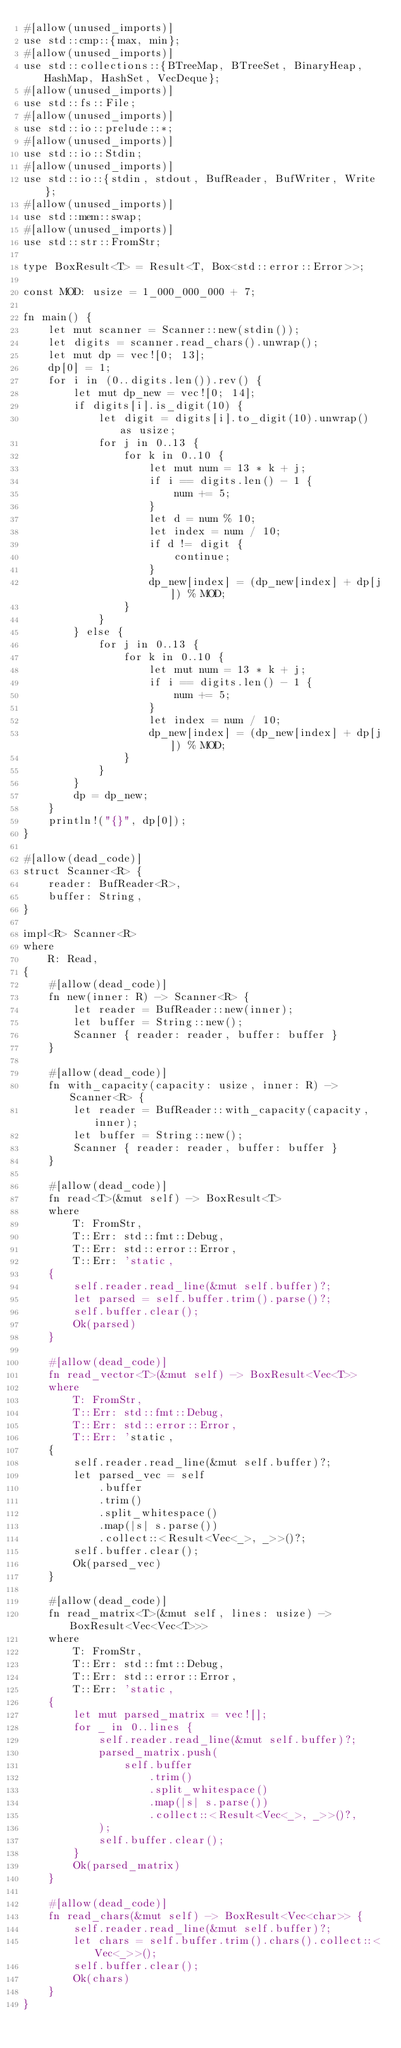Convert code to text. <code><loc_0><loc_0><loc_500><loc_500><_Rust_>#[allow(unused_imports)]
use std::cmp::{max, min};
#[allow(unused_imports)]
use std::collections::{BTreeMap, BTreeSet, BinaryHeap, HashMap, HashSet, VecDeque};
#[allow(unused_imports)]
use std::fs::File;
#[allow(unused_imports)]
use std::io::prelude::*;
#[allow(unused_imports)]
use std::io::Stdin;
#[allow(unused_imports)]
use std::io::{stdin, stdout, BufReader, BufWriter, Write};
#[allow(unused_imports)]
use std::mem::swap;
#[allow(unused_imports)]
use std::str::FromStr;

type BoxResult<T> = Result<T, Box<std::error::Error>>;

const MOD: usize = 1_000_000_000 + 7;

fn main() {
    let mut scanner = Scanner::new(stdin());
    let digits = scanner.read_chars().unwrap();
    let mut dp = vec![0; 13];
    dp[0] = 1;
    for i in (0..digits.len()).rev() {
        let mut dp_new = vec![0; 14];
        if digits[i].is_digit(10) {
            let digit = digits[i].to_digit(10).unwrap() as usize;
            for j in 0..13 {
                for k in 0..10 {
                    let mut num = 13 * k + j;
                    if i == digits.len() - 1 {
                        num += 5;
                    }
                    let d = num % 10;
                    let index = num / 10;
                    if d != digit {
                        continue;
                    }
                    dp_new[index] = (dp_new[index] + dp[j]) % MOD;
                }
            }
        } else {
            for j in 0..13 {
                for k in 0..10 {
                    let mut num = 13 * k + j;
                    if i == digits.len() - 1 {
                        num += 5;
                    }
                    let index = num / 10;
                    dp_new[index] = (dp_new[index] + dp[j]) % MOD;
                }
            }
        }
        dp = dp_new;
    }
    println!("{}", dp[0]);
}

#[allow(dead_code)]
struct Scanner<R> {
    reader: BufReader<R>,
    buffer: String,
}

impl<R> Scanner<R>
where
    R: Read,
{
    #[allow(dead_code)]
    fn new(inner: R) -> Scanner<R> {
        let reader = BufReader::new(inner);
        let buffer = String::new();
        Scanner { reader: reader, buffer: buffer }
    }

    #[allow(dead_code)]
    fn with_capacity(capacity: usize, inner: R) -> Scanner<R> {
        let reader = BufReader::with_capacity(capacity, inner);
        let buffer = String::new();
        Scanner { reader: reader, buffer: buffer }
    }

    #[allow(dead_code)]
    fn read<T>(&mut self) -> BoxResult<T>
    where
        T: FromStr,
        T::Err: std::fmt::Debug,
        T::Err: std::error::Error,
        T::Err: 'static,
    {
        self.reader.read_line(&mut self.buffer)?;
        let parsed = self.buffer.trim().parse()?;
        self.buffer.clear();
        Ok(parsed)
    }

    #[allow(dead_code)]
    fn read_vector<T>(&mut self) -> BoxResult<Vec<T>>
    where
        T: FromStr,
        T::Err: std::fmt::Debug,
        T::Err: std::error::Error,
        T::Err: 'static,
    {
        self.reader.read_line(&mut self.buffer)?;
        let parsed_vec = self
            .buffer
            .trim()
            .split_whitespace()
            .map(|s| s.parse())
            .collect::<Result<Vec<_>, _>>()?;
        self.buffer.clear();
        Ok(parsed_vec)
    }

    #[allow(dead_code)]
    fn read_matrix<T>(&mut self, lines: usize) -> BoxResult<Vec<Vec<T>>>
    where
        T: FromStr,
        T::Err: std::fmt::Debug,
        T::Err: std::error::Error,
        T::Err: 'static,
    {
        let mut parsed_matrix = vec![];
        for _ in 0..lines {
            self.reader.read_line(&mut self.buffer)?;
            parsed_matrix.push(
                self.buffer
                    .trim()
                    .split_whitespace()
                    .map(|s| s.parse())
                    .collect::<Result<Vec<_>, _>>()?,
            );
            self.buffer.clear();
        }
        Ok(parsed_matrix)
    }

    #[allow(dead_code)]
    fn read_chars(&mut self) -> BoxResult<Vec<char>> {
        self.reader.read_line(&mut self.buffer)?;
        let chars = self.buffer.trim().chars().collect::<Vec<_>>();
        self.buffer.clear();
        Ok(chars)
    }
}

</code> 